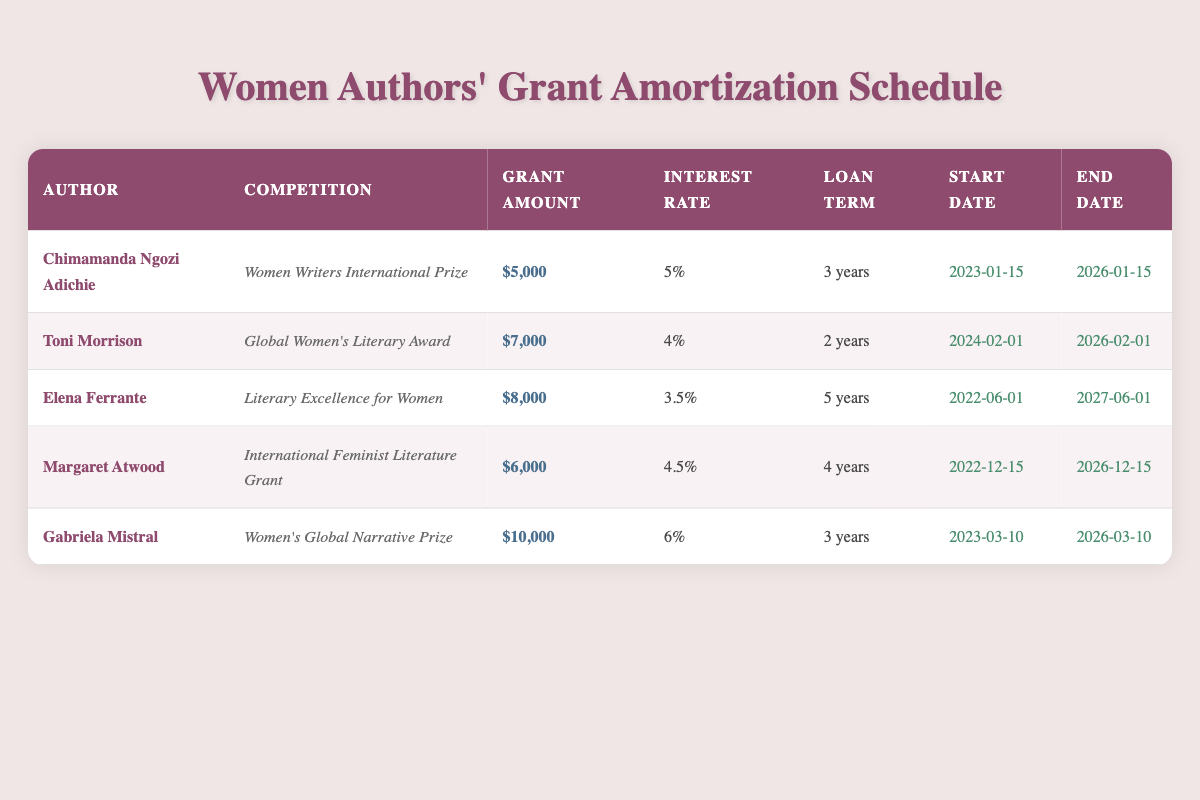What is the total grant amount awarded to all authors listed in the table? To find the total grant amount, we sum the individual grant amounts: 5000 + 7000 + 8000 + 6000 + 10000 = 40000.
Answer: 40000 Which author received the highest grant amount? The grant amounts are as follows: Adichie (5000), Morrison (7000), Ferrante (8000), Atwood (6000), and Mistral (10000). The highest amount is 10000, awarded to Gabriela Mistral.
Answer: Gabriela Mistral Is the interest rate for Toni Morrison's grant higher than the interest rate for Margaret Atwood's grant? Toni Morrison's interest rate is 4%, while Margaret Atwood's is 4.5%. Since 4.5% is greater than 4%, the answer is yes.
Answer: Yes What is the average interest rate for the grants listed in the table? The interest rates are 5%, 4%, 3.5%, 4.5%, and 6%. Summing these gives 5 + 4 + 3.5 + 4.5 + 6 = 23. Dividing by the number of grants (5) results in an average interest rate of 23/5 = 4.6%.
Answer: 4.6% Which grant will end first, according to the table? The end dates are: Adichie (2026-01-15), Morrison (2026-02-01), Ferrante (2027-06-01), Atwood (2026-12-15), and Mistral (2026-03-10). The earliest date is 2026-01-15 for Chimamanda Ngozi Adichie.
Answer: Chimamanda Ngozi Adichie 